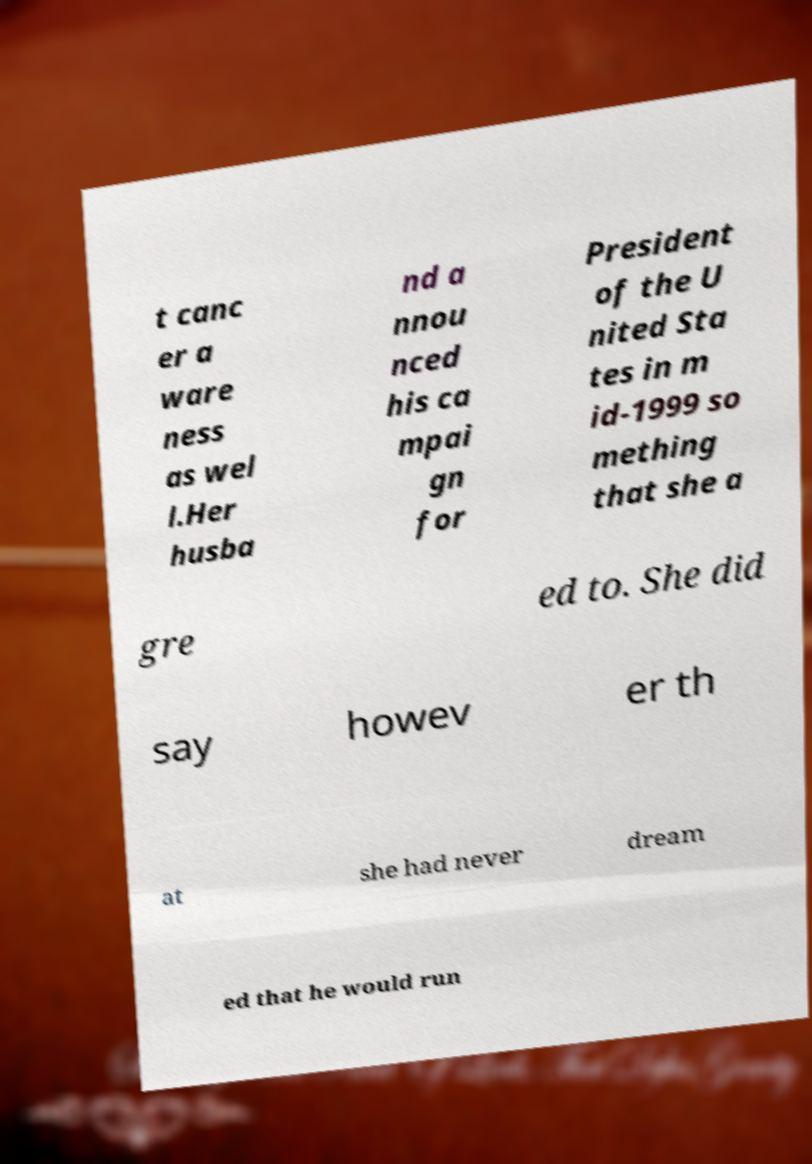Can you accurately transcribe the text from the provided image for me? t canc er a ware ness as wel l.Her husba nd a nnou nced his ca mpai gn for President of the U nited Sta tes in m id-1999 so mething that she a gre ed to. She did say howev er th at she had never dream ed that he would run 